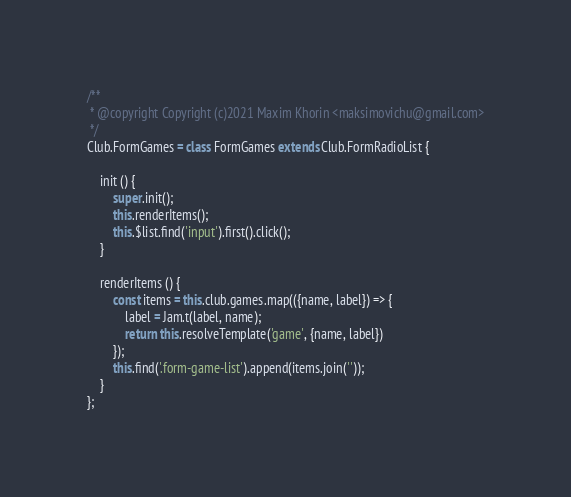Convert code to text. <code><loc_0><loc_0><loc_500><loc_500><_JavaScript_>/**
 * @copyright Copyright (c)2021 Maxim Khorin <maksimovichu@gmail.com>
 */
Club.FormGames = class FormGames extends Club.FormRadioList {

    init () {
        super.init();
        this.renderItems();
        this.$list.find('input').first().click();
    }

    renderItems () {
        const items = this.club.games.map(({name, label}) => {
            label = Jam.t(label, name);
            return this.resolveTemplate('game', {name, label})
        });
        this.find('.form-game-list').append(items.join(''));
    }
};</code> 